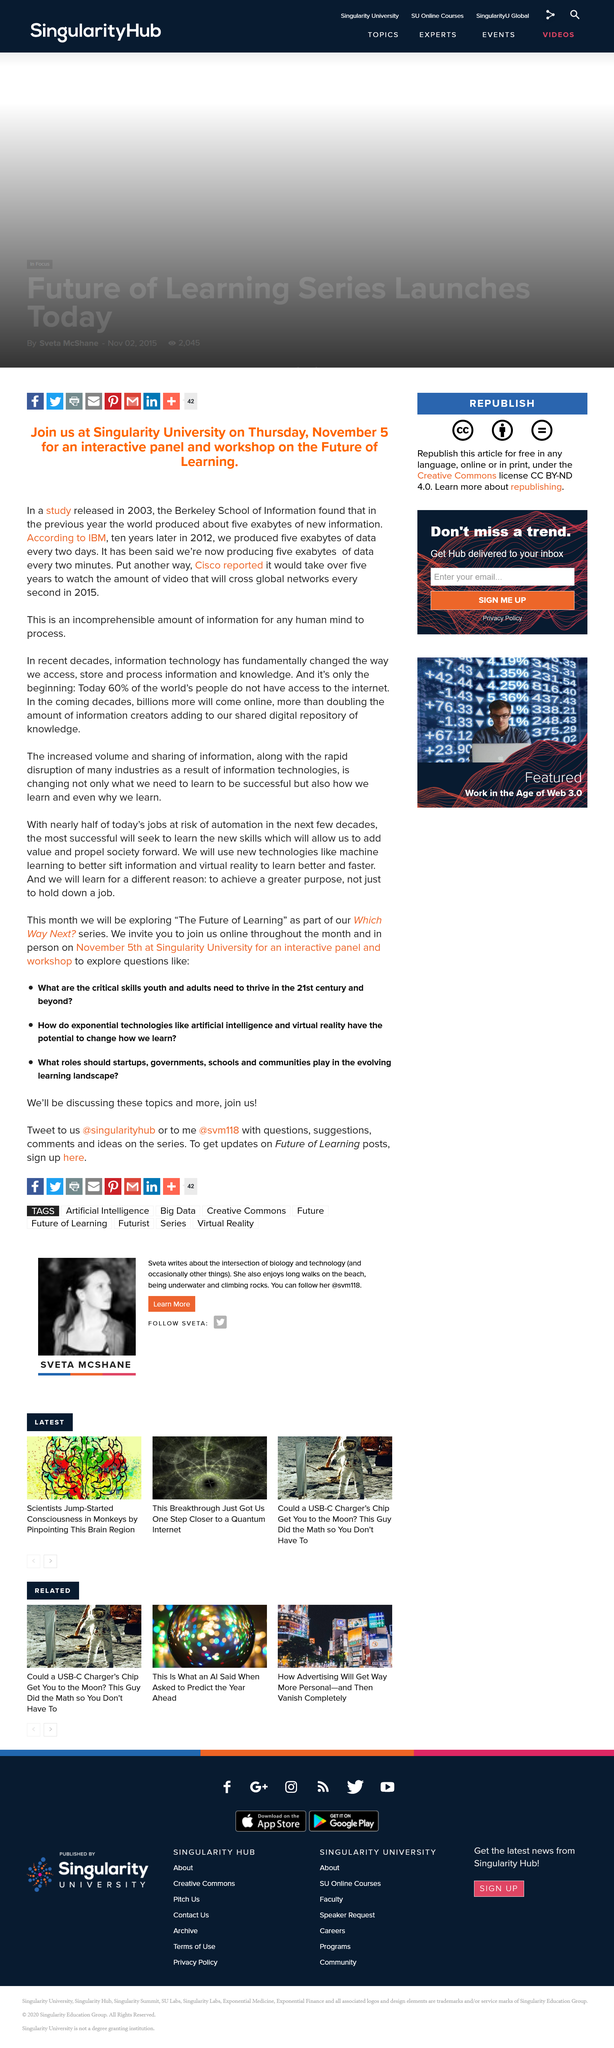Draw attention to some important aspects in this diagram. In 2012, we produced five exabytes of data. In 2003, a study was released by the Berkeley School of Information. According to recent estimates, approximately 60% of the global population does not have access to the internet. 